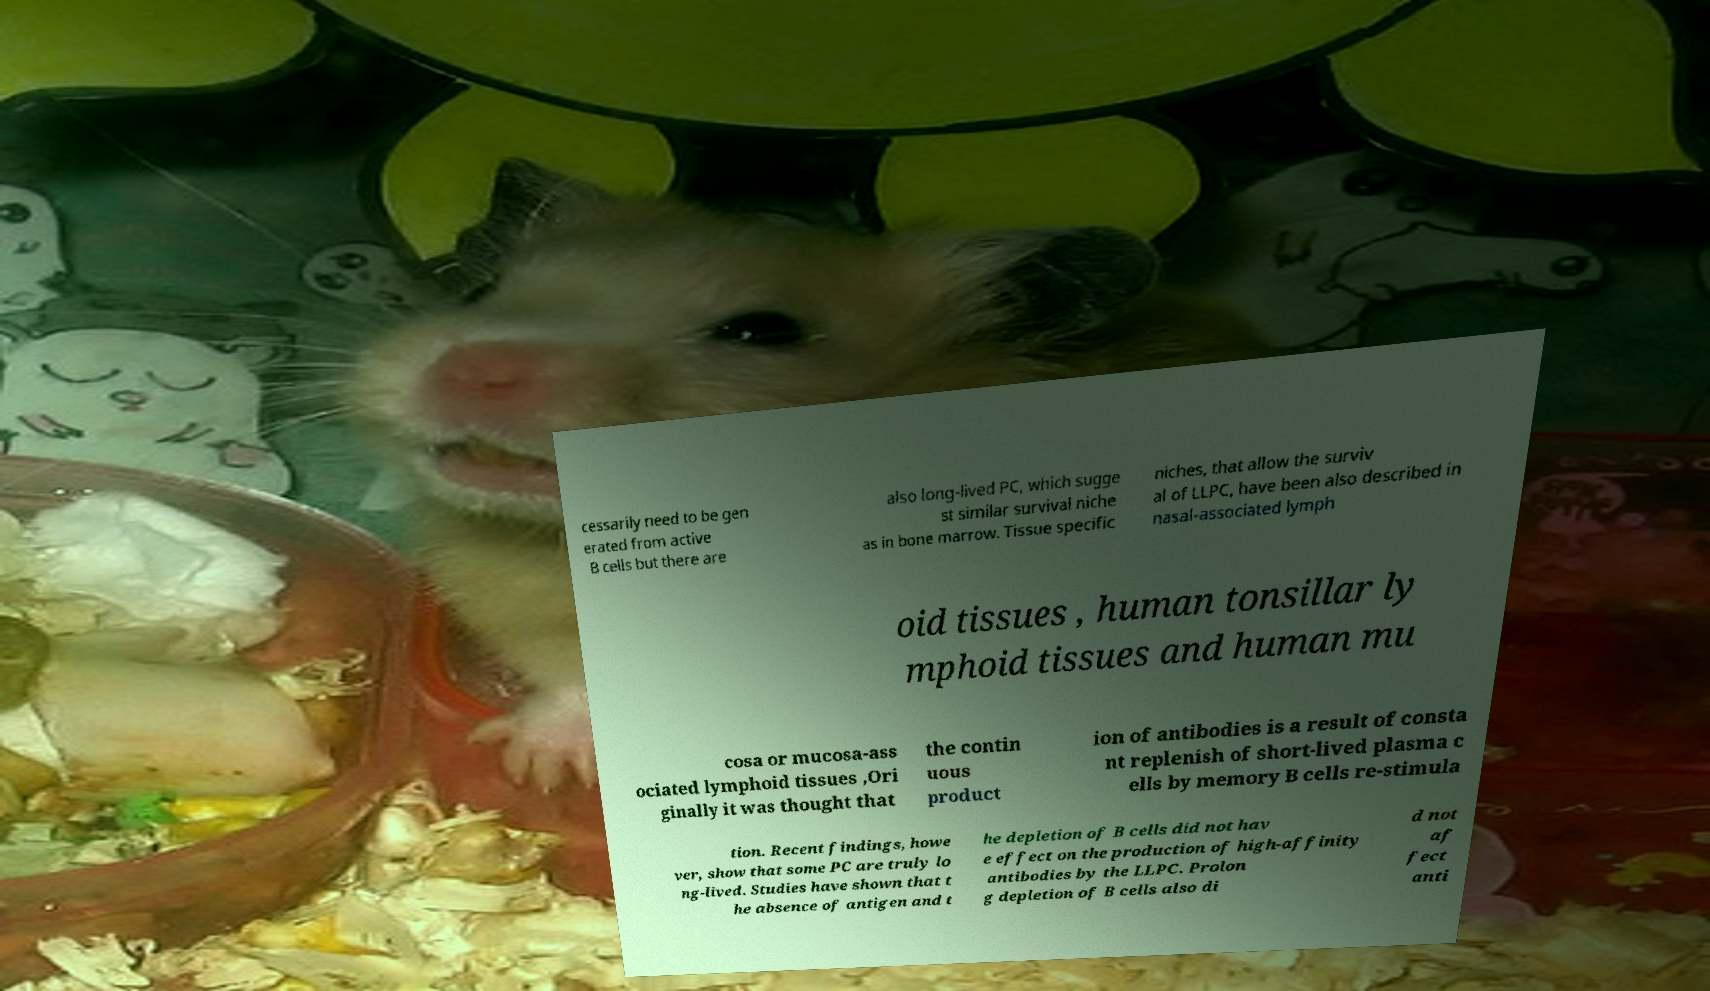Could you extract and type out the text from this image? cessarily need to be gen erated from active B cells but there are also long-lived PC, which sugge st similar survival niche as in bone marrow. Tissue specific niches, that allow the surviv al of LLPC, have been also described in nasal-associated lymph oid tissues , human tonsillar ly mphoid tissues and human mu cosa or mucosa-ass ociated lymphoid tissues ,Ori ginally it was thought that the contin uous product ion of antibodies is a result of consta nt replenish of short-lived plasma c ells by memory B cells re-stimula tion. Recent findings, howe ver, show that some PC are truly lo ng-lived. Studies have shown that t he absence of antigen and t he depletion of B cells did not hav e effect on the production of high-affinity antibodies by the LLPC. Prolon g depletion of B cells also di d not af fect anti 